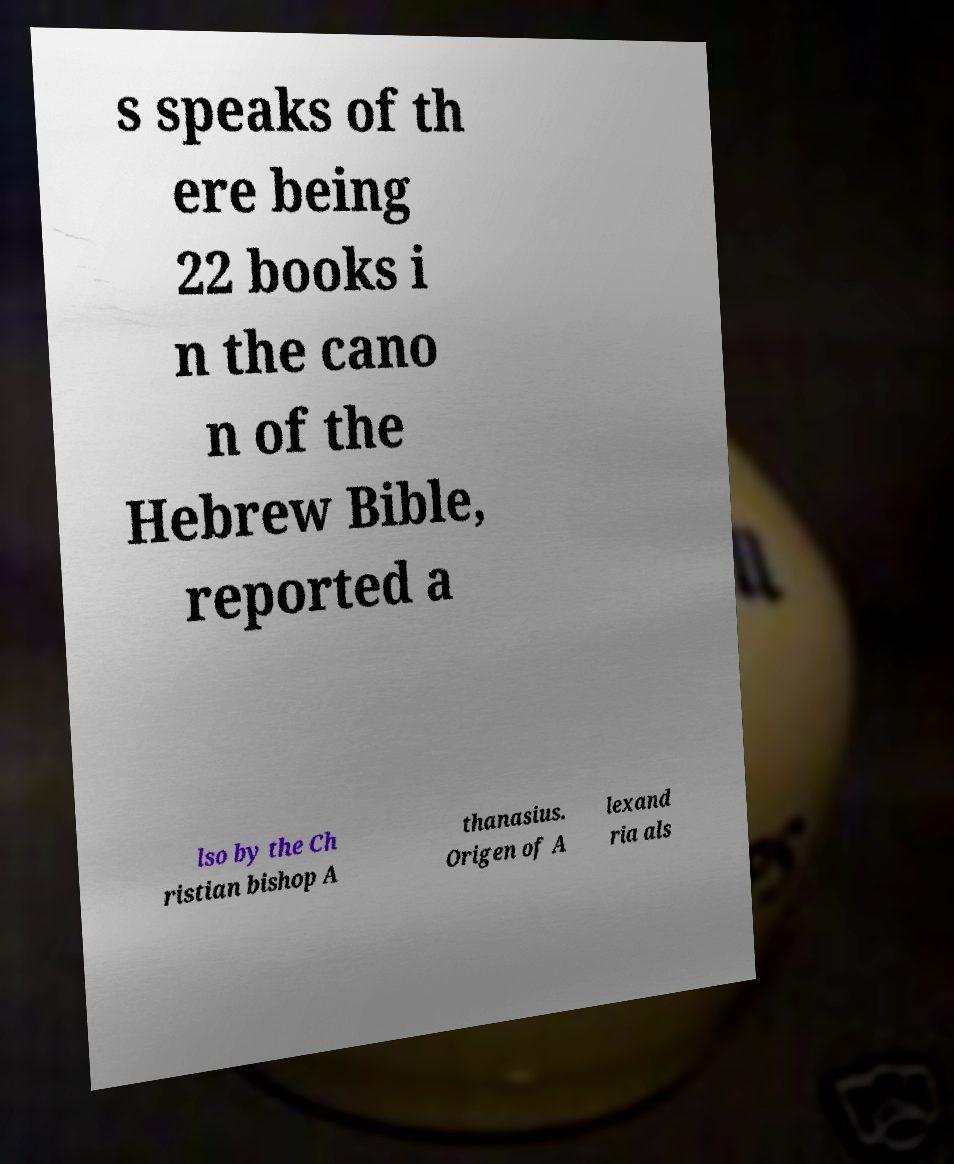Can you read and provide the text displayed in the image?This photo seems to have some interesting text. Can you extract and type it out for me? s speaks of th ere being 22 books i n the cano n of the Hebrew Bible, reported a lso by the Ch ristian bishop A thanasius. Origen of A lexand ria als 